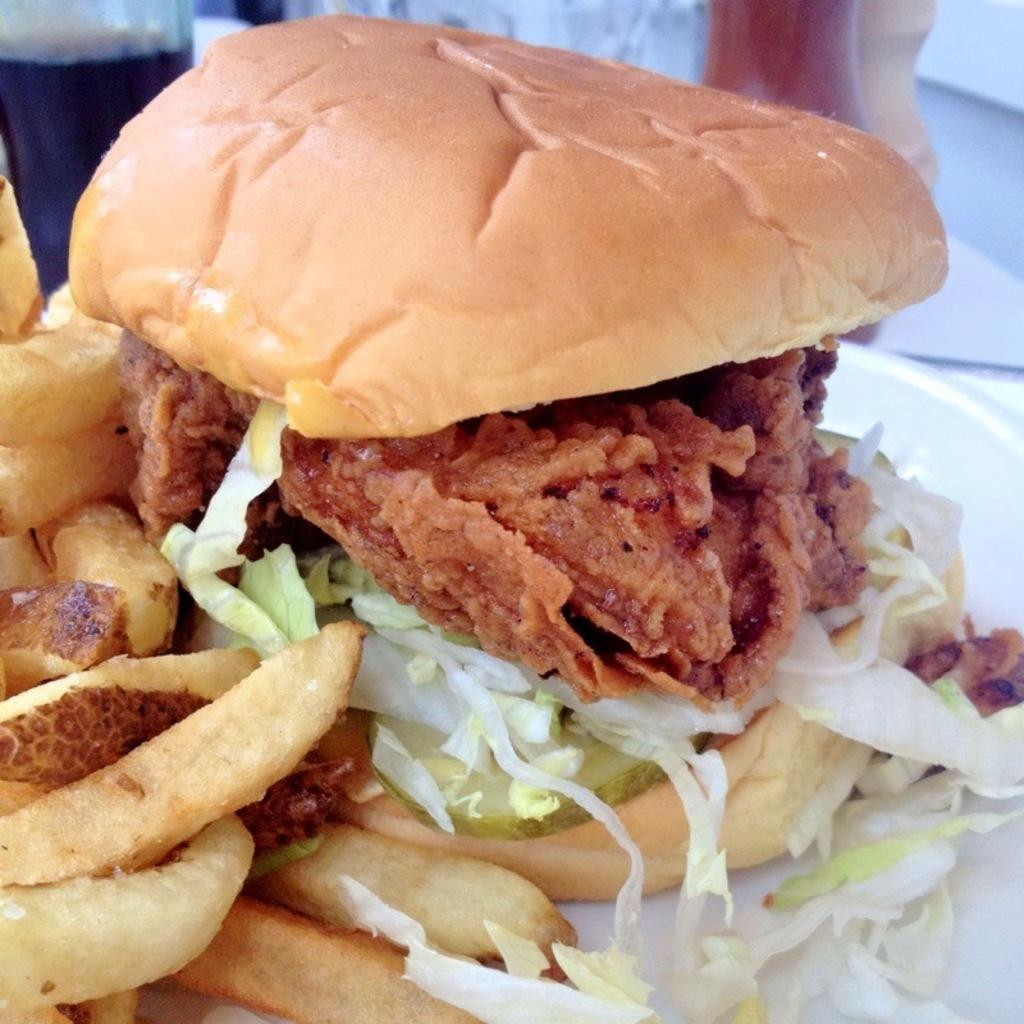What type of food is the main subject of the image? There is a burger in the image. What side dish is also visible in the image? There are french fries in the image. What type of plants can be seen growing in the burger? There are no plants visible in the burger; it is a food item made of various ingredients. 